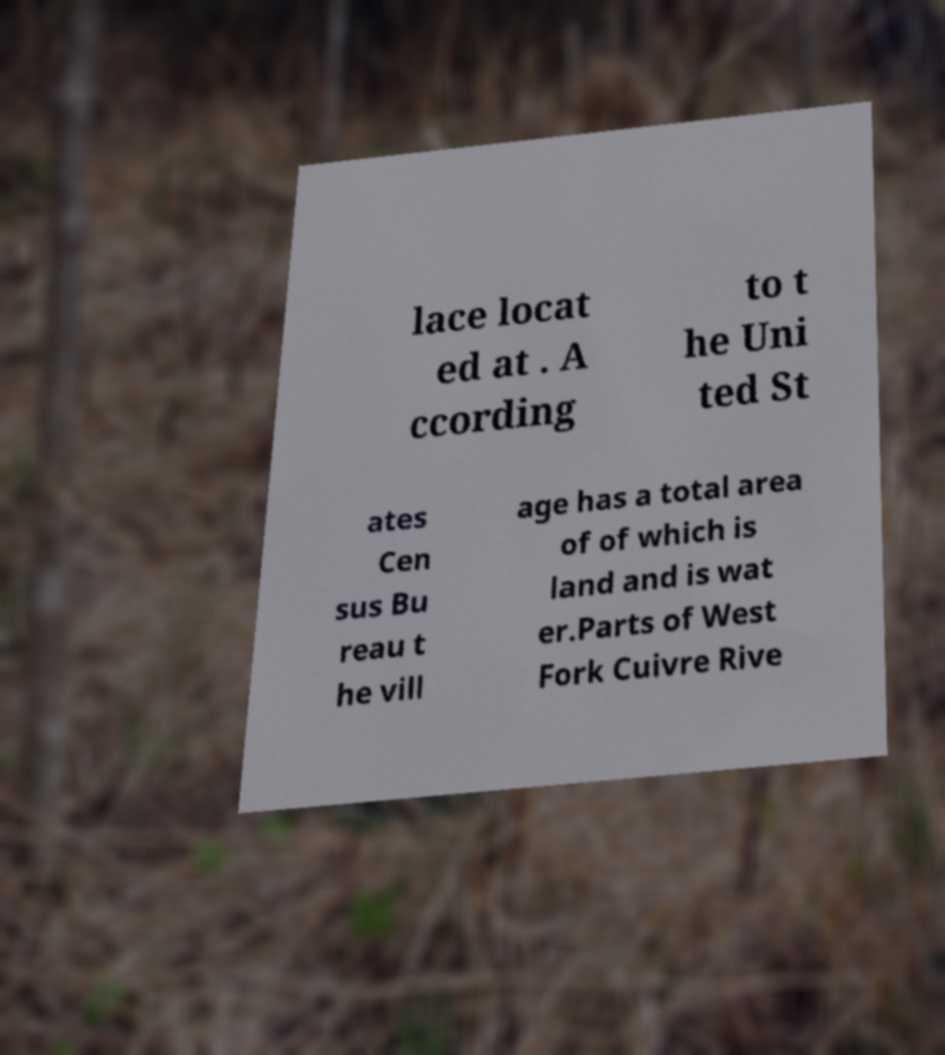Could you extract and type out the text from this image? lace locat ed at . A ccording to t he Uni ted St ates Cen sus Bu reau t he vill age has a total area of of which is land and is wat er.Parts of West Fork Cuivre Rive 